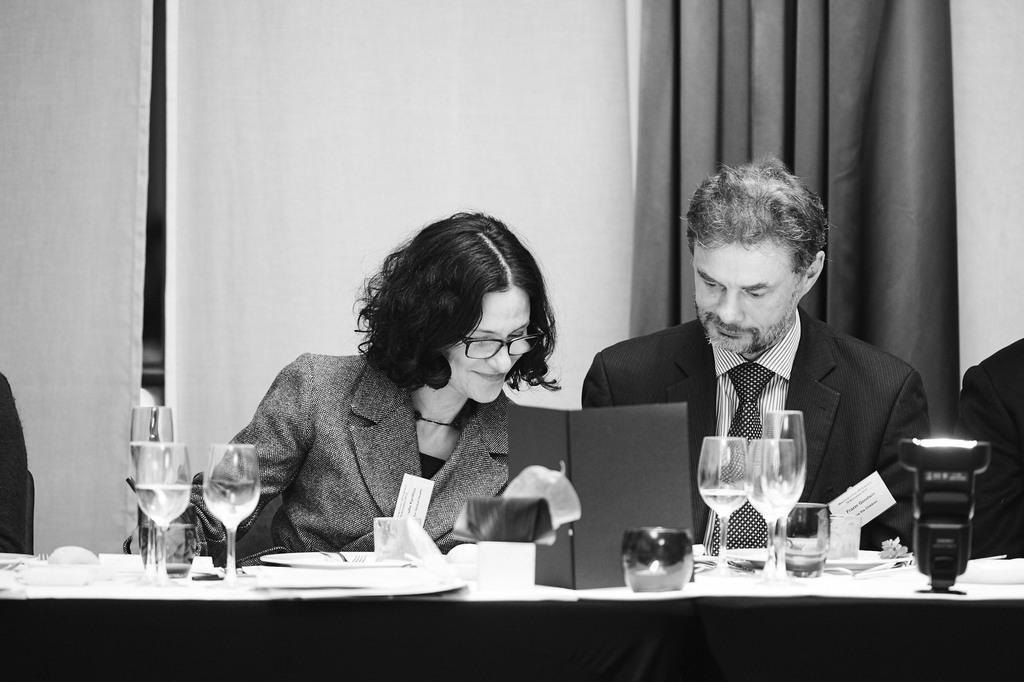How would you summarize this image in a sentence or two? In this picture we can see two people sitting on the chair in front of the table and on the table we have some glasses and some things on it. 